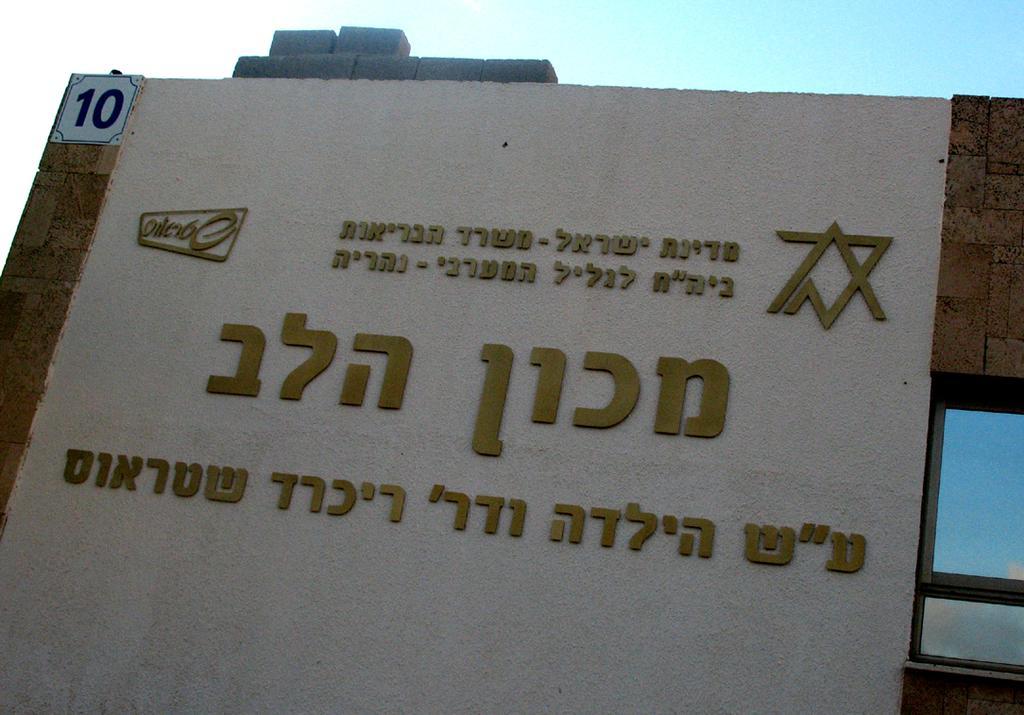In one or two sentences, can you explain what this image depicts? In the picture we can see a board with some information and beside it, we can see a screen which is blue in color and behind the board we can see the sky. 